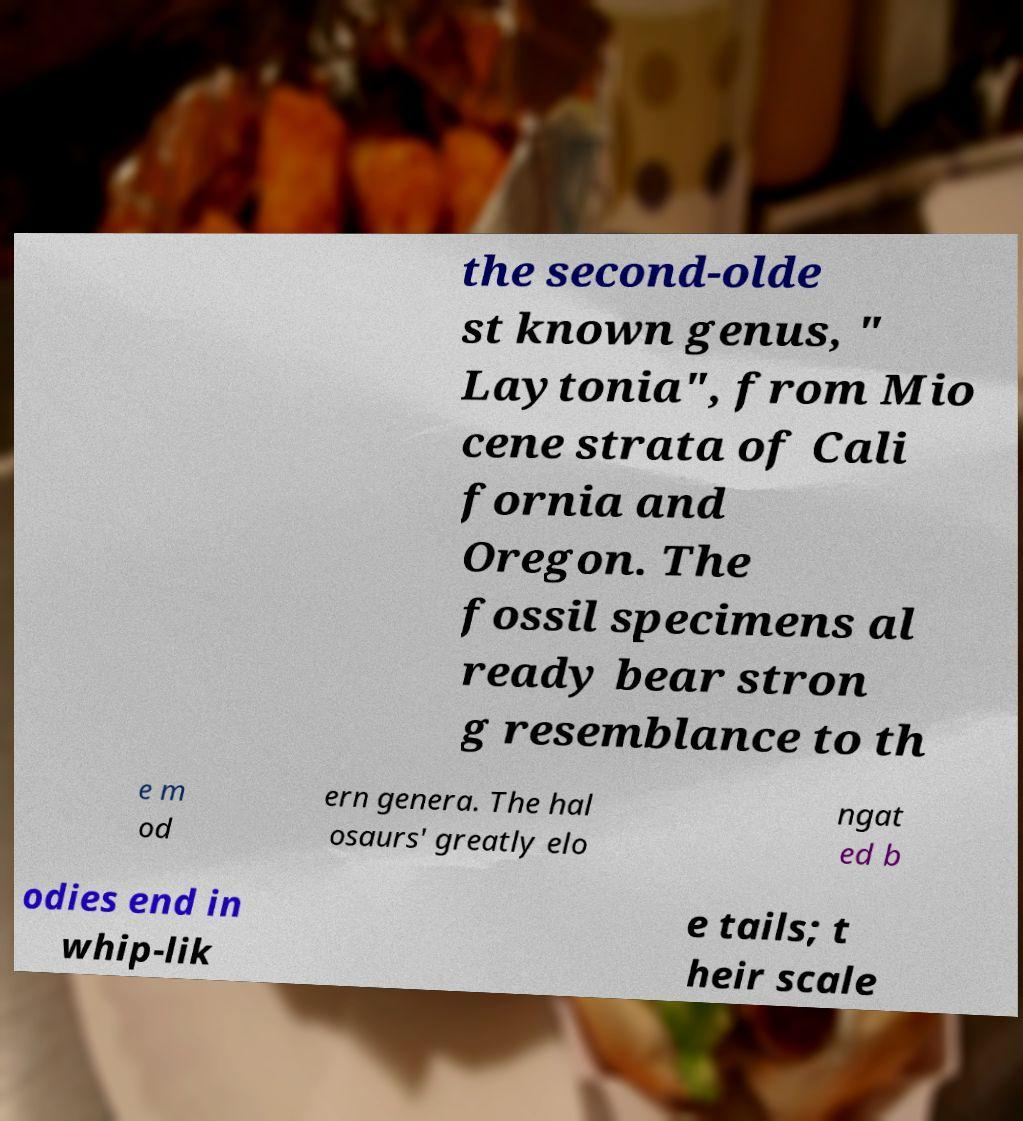Please identify and transcribe the text found in this image. the second-olde st known genus, " Laytonia", from Mio cene strata of Cali fornia and Oregon. The fossil specimens al ready bear stron g resemblance to th e m od ern genera. The hal osaurs' greatly elo ngat ed b odies end in whip-lik e tails; t heir scale 